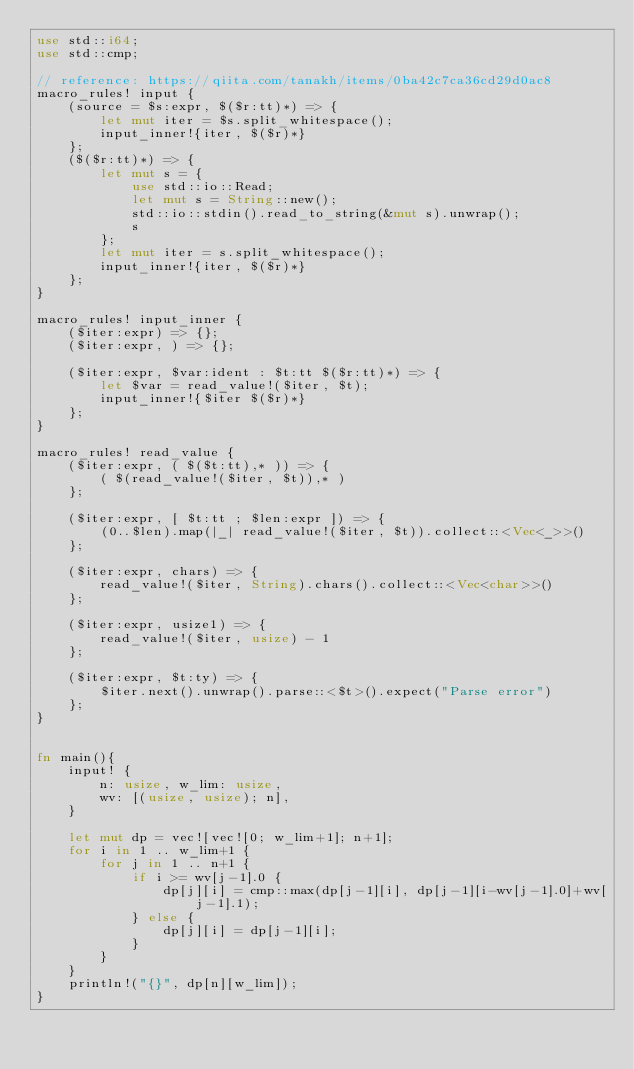Convert code to text. <code><loc_0><loc_0><loc_500><loc_500><_Rust_>use std::i64;
use std::cmp;

// reference: https://qiita.com/tanakh/items/0ba42c7ca36cd29d0ac8
macro_rules! input {
    (source = $s:expr, $($r:tt)*) => {
        let mut iter = $s.split_whitespace();
        input_inner!{iter, $($r)*}
    };
    ($($r:tt)*) => {
        let mut s = {
            use std::io::Read;
            let mut s = String::new();
            std::io::stdin().read_to_string(&mut s).unwrap();
            s
        };
        let mut iter = s.split_whitespace();
        input_inner!{iter, $($r)*}
    };
}

macro_rules! input_inner {
    ($iter:expr) => {};
    ($iter:expr, ) => {};

    ($iter:expr, $var:ident : $t:tt $($r:tt)*) => {
        let $var = read_value!($iter, $t);
        input_inner!{$iter $($r)*}
    };
}

macro_rules! read_value {
    ($iter:expr, ( $($t:tt),* )) => {
        ( $(read_value!($iter, $t)),* )
    };

    ($iter:expr, [ $t:tt ; $len:expr ]) => {
        (0..$len).map(|_| read_value!($iter, $t)).collect::<Vec<_>>()
    };

    ($iter:expr, chars) => {
        read_value!($iter, String).chars().collect::<Vec<char>>()
    };

    ($iter:expr, usize1) => {
        read_value!($iter, usize) - 1
    };

    ($iter:expr, $t:ty) => {
        $iter.next().unwrap().parse::<$t>().expect("Parse error")
    };
}


fn main(){
    input! {
        n: usize, w_lim: usize,
        wv: [(usize, usize); n],
    }

    let mut dp = vec![vec![0; w_lim+1]; n+1];
    for i in 1 .. w_lim+1 {
        for j in 1 .. n+1 {
            if i >= wv[j-1].0 {
                dp[j][i] = cmp::max(dp[j-1][i], dp[j-1][i-wv[j-1].0]+wv[j-1].1);
            } else {
                dp[j][i] = dp[j-1][i];
            }
        }
    }
    println!("{}", dp[n][w_lim]);
}


</code> 